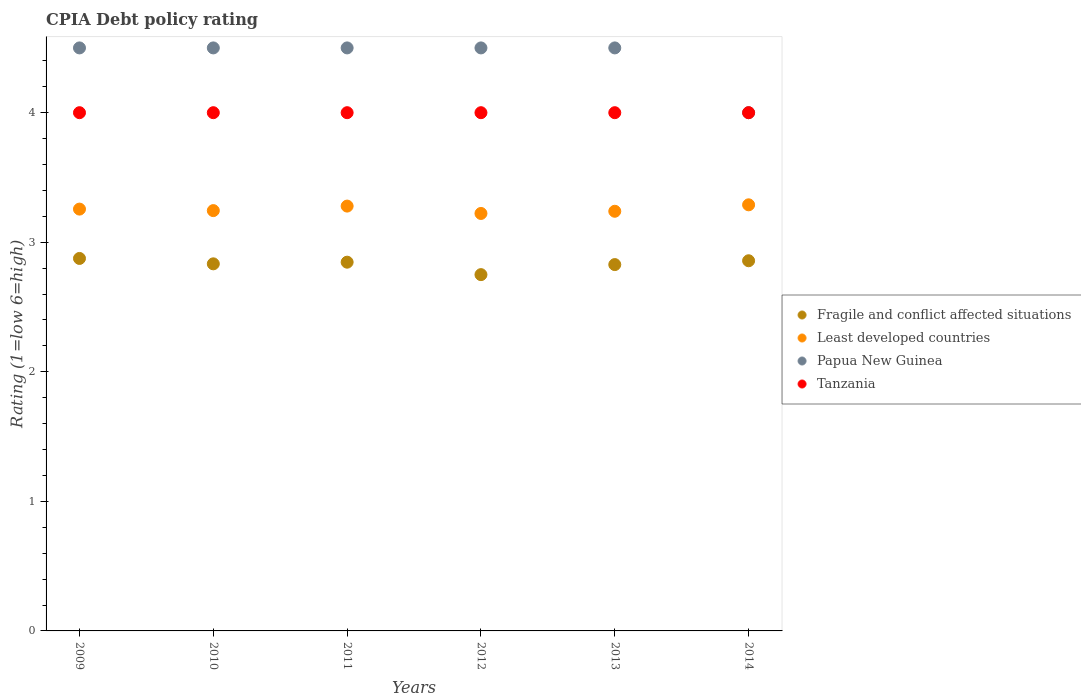How many different coloured dotlines are there?
Provide a succinct answer. 4. Is the number of dotlines equal to the number of legend labels?
Your answer should be very brief. Yes. What is the CPIA rating in Least developed countries in 2010?
Provide a succinct answer. 3.24. Across all years, what is the minimum CPIA rating in Papua New Guinea?
Provide a short and direct response. 4. What is the total CPIA rating in Fragile and conflict affected situations in the graph?
Your answer should be compact. 16.99. What is the difference between the CPIA rating in Least developed countries in 2009 and that in 2011?
Your response must be concise. -0.02. What is the difference between the CPIA rating in Least developed countries in 2010 and the CPIA rating in Fragile and conflict affected situations in 2012?
Ensure brevity in your answer.  0.49. What is the average CPIA rating in Fragile and conflict affected situations per year?
Offer a very short reply. 2.83. In the year 2009, what is the difference between the CPIA rating in Least developed countries and CPIA rating in Papua New Guinea?
Make the answer very short. -1.24. In how many years, is the CPIA rating in Tanzania greater than 4.2?
Make the answer very short. 0. What is the ratio of the CPIA rating in Least developed countries in 2011 to that in 2013?
Offer a terse response. 1.01. Is the difference between the CPIA rating in Least developed countries in 2009 and 2013 greater than the difference between the CPIA rating in Papua New Guinea in 2009 and 2013?
Ensure brevity in your answer.  Yes. What is the difference between the highest and the second highest CPIA rating in Papua New Guinea?
Give a very brief answer. 0. Is it the case that in every year, the sum of the CPIA rating in Tanzania and CPIA rating in Papua New Guinea  is greater than the CPIA rating in Least developed countries?
Your answer should be very brief. Yes. Does the CPIA rating in Fragile and conflict affected situations monotonically increase over the years?
Give a very brief answer. No. Is the CPIA rating in Tanzania strictly less than the CPIA rating in Fragile and conflict affected situations over the years?
Keep it short and to the point. No. How many dotlines are there?
Offer a terse response. 4. How many years are there in the graph?
Offer a very short reply. 6. What is the difference between two consecutive major ticks on the Y-axis?
Give a very brief answer. 1. Are the values on the major ticks of Y-axis written in scientific E-notation?
Your response must be concise. No. Does the graph contain any zero values?
Keep it short and to the point. No. How are the legend labels stacked?
Provide a succinct answer. Vertical. What is the title of the graph?
Provide a succinct answer. CPIA Debt policy rating. What is the label or title of the X-axis?
Provide a succinct answer. Years. What is the Rating (1=low 6=high) of Fragile and conflict affected situations in 2009?
Give a very brief answer. 2.88. What is the Rating (1=low 6=high) of Least developed countries in 2009?
Make the answer very short. 3.26. What is the Rating (1=low 6=high) of Fragile and conflict affected situations in 2010?
Keep it short and to the point. 2.83. What is the Rating (1=low 6=high) in Least developed countries in 2010?
Offer a terse response. 3.24. What is the Rating (1=low 6=high) in Tanzania in 2010?
Provide a succinct answer. 4. What is the Rating (1=low 6=high) in Fragile and conflict affected situations in 2011?
Give a very brief answer. 2.85. What is the Rating (1=low 6=high) of Least developed countries in 2011?
Your response must be concise. 3.28. What is the Rating (1=low 6=high) in Papua New Guinea in 2011?
Provide a short and direct response. 4.5. What is the Rating (1=low 6=high) in Fragile and conflict affected situations in 2012?
Keep it short and to the point. 2.75. What is the Rating (1=low 6=high) in Least developed countries in 2012?
Keep it short and to the point. 3.22. What is the Rating (1=low 6=high) in Papua New Guinea in 2012?
Your response must be concise. 4.5. What is the Rating (1=low 6=high) in Fragile and conflict affected situations in 2013?
Your answer should be compact. 2.83. What is the Rating (1=low 6=high) in Least developed countries in 2013?
Keep it short and to the point. 3.24. What is the Rating (1=low 6=high) in Tanzania in 2013?
Provide a short and direct response. 4. What is the Rating (1=low 6=high) of Fragile and conflict affected situations in 2014?
Give a very brief answer. 2.86. What is the Rating (1=low 6=high) in Least developed countries in 2014?
Ensure brevity in your answer.  3.29. What is the Rating (1=low 6=high) of Tanzania in 2014?
Ensure brevity in your answer.  4. Across all years, what is the maximum Rating (1=low 6=high) in Fragile and conflict affected situations?
Ensure brevity in your answer.  2.88. Across all years, what is the maximum Rating (1=low 6=high) of Least developed countries?
Offer a very short reply. 3.29. Across all years, what is the minimum Rating (1=low 6=high) of Fragile and conflict affected situations?
Provide a short and direct response. 2.75. Across all years, what is the minimum Rating (1=low 6=high) of Least developed countries?
Keep it short and to the point. 3.22. What is the total Rating (1=low 6=high) in Fragile and conflict affected situations in the graph?
Offer a terse response. 16.99. What is the total Rating (1=low 6=high) in Least developed countries in the graph?
Your answer should be compact. 19.53. What is the total Rating (1=low 6=high) in Tanzania in the graph?
Offer a very short reply. 24. What is the difference between the Rating (1=low 6=high) in Fragile and conflict affected situations in 2009 and that in 2010?
Keep it short and to the point. 0.04. What is the difference between the Rating (1=low 6=high) in Least developed countries in 2009 and that in 2010?
Offer a very short reply. 0.01. What is the difference between the Rating (1=low 6=high) in Tanzania in 2009 and that in 2010?
Your answer should be very brief. 0. What is the difference between the Rating (1=low 6=high) in Fragile and conflict affected situations in 2009 and that in 2011?
Your answer should be very brief. 0.03. What is the difference between the Rating (1=low 6=high) of Least developed countries in 2009 and that in 2011?
Keep it short and to the point. -0.02. What is the difference between the Rating (1=low 6=high) of Papua New Guinea in 2009 and that in 2011?
Keep it short and to the point. 0. What is the difference between the Rating (1=low 6=high) in Least developed countries in 2009 and that in 2012?
Provide a short and direct response. 0.03. What is the difference between the Rating (1=low 6=high) in Papua New Guinea in 2009 and that in 2012?
Ensure brevity in your answer.  0. What is the difference between the Rating (1=low 6=high) in Tanzania in 2009 and that in 2012?
Your answer should be compact. 0. What is the difference between the Rating (1=low 6=high) of Fragile and conflict affected situations in 2009 and that in 2013?
Ensure brevity in your answer.  0.05. What is the difference between the Rating (1=low 6=high) of Least developed countries in 2009 and that in 2013?
Make the answer very short. 0.02. What is the difference between the Rating (1=low 6=high) of Papua New Guinea in 2009 and that in 2013?
Offer a very short reply. 0. What is the difference between the Rating (1=low 6=high) in Tanzania in 2009 and that in 2013?
Provide a succinct answer. 0. What is the difference between the Rating (1=low 6=high) in Fragile and conflict affected situations in 2009 and that in 2014?
Provide a succinct answer. 0.02. What is the difference between the Rating (1=low 6=high) of Least developed countries in 2009 and that in 2014?
Make the answer very short. -0.03. What is the difference between the Rating (1=low 6=high) in Tanzania in 2009 and that in 2014?
Offer a terse response. 0. What is the difference between the Rating (1=low 6=high) in Fragile and conflict affected situations in 2010 and that in 2011?
Ensure brevity in your answer.  -0.01. What is the difference between the Rating (1=low 6=high) in Least developed countries in 2010 and that in 2011?
Offer a very short reply. -0.03. What is the difference between the Rating (1=low 6=high) in Fragile and conflict affected situations in 2010 and that in 2012?
Ensure brevity in your answer.  0.08. What is the difference between the Rating (1=low 6=high) in Least developed countries in 2010 and that in 2012?
Give a very brief answer. 0.02. What is the difference between the Rating (1=low 6=high) of Tanzania in 2010 and that in 2012?
Offer a very short reply. 0. What is the difference between the Rating (1=low 6=high) in Fragile and conflict affected situations in 2010 and that in 2013?
Your answer should be very brief. 0.01. What is the difference between the Rating (1=low 6=high) of Least developed countries in 2010 and that in 2013?
Your answer should be very brief. 0.01. What is the difference between the Rating (1=low 6=high) in Papua New Guinea in 2010 and that in 2013?
Keep it short and to the point. 0. What is the difference between the Rating (1=low 6=high) of Tanzania in 2010 and that in 2013?
Your answer should be very brief. 0. What is the difference between the Rating (1=low 6=high) of Fragile and conflict affected situations in 2010 and that in 2014?
Provide a succinct answer. -0.02. What is the difference between the Rating (1=low 6=high) of Least developed countries in 2010 and that in 2014?
Your answer should be very brief. -0.04. What is the difference between the Rating (1=low 6=high) of Papua New Guinea in 2010 and that in 2014?
Provide a short and direct response. 0.5. What is the difference between the Rating (1=low 6=high) of Fragile and conflict affected situations in 2011 and that in 2012?
Ensure brevity in your answer.  0.1. What is the difference between the Rating (1=low 6=high) in Least developed countries in 2011 and that in 2012?
Offer a terse response. 0.06. What is the difference between the Rating (1=low 6=high) of Fragile and conflict affected situations in 2011 and that in 2013?
Provide a succinct answer. 0.02. What is the difference between the Rating (1=low 6=high) in Least developed countries in 2011 and that in 2013?
Make the answer very short. 0.04. What is the difference between the Rating (1=low 6=high) in Papua New Guinea in 2011 and that in 2013?
Offer a terse response. 0. What is the difference between the Rating (1=low 6=high) of Fragile and conflict affected situations in 2011 and that in 2014?
Offer a terse response. -0.01. What is the difference between the Rating (1=low 6=high) of Least developed countries in 2011 and that in 2014?
Your answer should be compact. -0.01. What is the difference between the Rating (1=low 6=high) of Papua New Guinea in 2011 and that in 2014?
Your answer should be compact. 0.5. What is the difference between the Rating (1=low 6=high) of Fragile and conflict affected situations in 2012 and that in 2013?
Offer a very short reply. -0.08. What is the difference between the Rating (1=low 6=high) in Least developed countries in 2012 and that in 2013?
Make the answer very short. -0.02. What is the difference between the Rating (1=low 6=high) in Papua New Guinea in 2012 and that in 2013?
Give a very brief answer. 0. What is the difference between the Rating (1=low 6=high) of Fragile and conflict affected situations in 2012 and that in 2014?
Ensure brevity in your answer.  -0.11. What is the difference between the Rating (1=low 6=high) in Least developed countries in 2012 and that in 2014?
Offer a terse response. -0.07. What is the difference between the Rating (1=low 6=high) of Papua New Guinea in 2012 and that in 2014?
Your answer should be very brief. 0.5. What is the difference between the Rating (1=low 6=high) in Fragile and conflict affected situations in 2013 and that in 2014?
Provide a succinct answer. -0.03. What is the difference between the Rating (1=low 6=high) of Least developed countries in 2013 and that in 2014?
Your answer should be compact. -0.05. What is the difference between the Rating (1=low 6=high) in Papua New Guinea in 2013 and that in 2014?
Give a very brief answer. 0.5. What is the difference between the Rating (1=low 6=high) of Fragile and conflict affected situations in 2009 and the Rating (1=low 6=high) of Least developed countries in 2010?
Give a very brief answer. -0.37. What is the difference between the Rating (1=low 6=high) of Fragile and conflict affected situations in 2009 and the Rating (1=low 6=high) of Papua New Guinea in 2010?
Give a very brief answer. -1.62. What is the difference between the Rating (1=low 6=high) of Fragile and conflict affected situations in 2009 and the Rating (1=low 6=high) of Tanzania in 2010?
Offer a terse response. -1.12. What is the difference between the Rating (1=low 6=high) in Least developed countries in 2009 and the Rating (1=low 6=high) in Papua New Guinea in 2010?
Offer a terse response. -1.24. What is the difference between the Rating (1=low 6=high) of Least developed countries in 2009 and the Rating (1=low 6=high) of Tanzania in 2010?
Give a very brief answer. -0.74. What is the difference between the Rating (1=low 6=high) in Fragile and conflict affected situations in 2009 and the Rating (1=low 6=high) in Least developed countries in 2011?
Give a very brief answer. -0.4. What is the difference between the Rating (1=low 6=high) of Fragile and conflict affected situations in 2009 and the Rating (1=low 6=high) of Papua New Guinea in 2011?
Offer a very short reply. -1.62. What is the difference between the Rating (1=low 6=high) in Fragile and conflict affected situations in 2009 and the Rating (1=low 6=high) in Tanzania in 2011?
Your response must be concise. -1.12. What is the difference between the Rating (1=low 6=high) in Least developed countries in 2009 and the Rating (1=low 6=high) in Papua New Guinea in 2011?
Give a very brief answer. -1.24. What is the difference between the Rating (1=low 6=high) of Least developed countries in 2009 and the Rating (1=low 6=high) of Tanzania in 2011?
Make the answer very short. -0.74. What is the difference between the Rating (1=low 6=high) in Papua New Guinea in 2009 and the Rating (1=low 6=high) in Tanzania in 2011?
Make the answer very short. 0.5. What is the difference between the Rating (1=low 6=high) in Fragile and conflict affected situations in 2009 and the Rating (1=low 6=high) in Least developed countries in 2012?
Your response must be concise. -0.35. What is the difference between the Rating (1=low 6=high) in Fragile and conflict affected situations in 2009 and the Rating (1=low 6=high) in Papua New Guinea in 2012?
Your response must be concise. -1.62. What is the difference between the Rating (1=low 6=high) in Fragile and conflict affected situations in 2009 and the Rating (1=low 6=high) in Tanzania in 2012?
Provide a succinct answer. -1.12. What is the difference between the Rating (1=low 6=high) in Least developed countries in 2009 and the Rating (1=low 6=high) in Papua New Guinea in 2012?
Give a very brief answer. -1.24. What is the difference between the Rating (1=low 6=high) in Least developed countries in 2009 and the Rating (1=low 6=high) in Tanzania in 2012?
Keep it short and to the point. -0.74. What is the difference between the Rating (1=low 6=high) of Papua New Guinea in 2009 and the Rating (1=low 6=high) of Tanzania in 2012?
Your answer should be compact. 0.5. What is the difference between the Rating (1=low 6=high) of Fragile and conflict affected situations in 2009 and the Rating (1=low 6=high) of Least developed countries in 2013?
Give a very brief answer. -0.36. What is the difference between the Rating (1=low 6=high) of Fragile and conflict affected situations in 2009 and the Rating (1=low 6=high) of Papua New Guinea in 2013?
Give a very brief answer. -1.62. What is the difference between the Rating (1=low 6=high) in Fragile and conflict affected situations in 2009 and the Rating (1=low 6=high) in Tanzania in 2013?
Make the answer very short. -1.12. What is the difference between the Rating (1=low 6=high) in Least developed countries in 2009 and the Rating (1=low 6=high) in Papua New Guinea in 2013?
Make the answer very short. -1.24. What is the difference between the Rating (1=low 6=high) of Least developed countries in 2009 and the Rating (1=low 6=high) of Tanzania in 2013?
Keep it short and to the point. -0.74. What is the difference between the Rating (1=low 6=high) in Papua New Guinea in 2009 and the Rating (1=low 6=high) in Tanzania in 2013?
Give a very brief answer. 0.5. What is the difference between the Rating (1=low 6=high) in Fragile and conflict affected situations in 2009 and the Rating (1=low 6=high) in Least developed countries in 2014?
Offer a terse response. -0.41. What is the difference between the Rating (1=low 6=high) in Fragile and conflict affected situations in 2009 and the Rating (1=low 6=high) in Papua New Guinea in 2014?
Your answer should be very brief. -1.12. What is the difference between the Rating (1=low 6=high) in Fragile and conflict affected situations in 2009 and the Rating (1=low 6=high) in Tanzania in 2014?
Your answer should be very brief. -1.12. What is the difference between the Rating (1=low 6=high) in Least developed countries in 2009 and the Rating (1=low 6=high) in Papua New Guinea in 2014?
Your answer should be compact. -0.74. What is the difference between the Rating (1=low 6=high) of Least developed countries in 2009 and the Rating (1=low 6=high) of Tanzania in 2014?
Your response must be concise. -0.74. What is the difference between the Rating (1=low 6=high) in Fragile and conflict affected situations in 2010 and the Rating (1=low 6=high) in Least developed countries in 2011?
Provide a short and direct response. -0.45. What is the difference between the Rating (1=low 6=high) of Fragile and conflict affected situations in 2010 and the Rating (1=low 6=high) of Papua New Guinea in 2011?
Give a very brief answer. -1.67. What is the difference between the Rating (1=low 6=high) in Fragile and conflict affected situations in 2010 and the Rating (1=low 6=high) in Tanzania in 2011?
Give a very brief answer. -1.17. What is the difference between the Rating (1=low 6=high) in Least developed countries in 2010 and the Rating (1=low 6=high) in Papua New Guinea in 2011?
Keep it short and to the point. -1.26. What is the difference between the Rating (1=low 6=high) of Least developed countries in 2010 and the Rating (1=low 6=high) of Tanzania in 2011?
Make the answer very short. -0.76. What is the difference between the Rating (1=low 6=high) of Papua New Guinea in 2010 and the Rating (1=low 6=high) of Tanzania in 2011?
Your answer should be very brief. 0.5. What is the difference between the Rating (1=low 6=high) of Fragile and conflict affected situations in 2010 and the Rating (1=low 6=high) of Least developed countries in 2012?
Give a very brief answer. -0.39. What is the difference between the Rating (1=low 6=high) of Fragile and conflict affected situations in 2010 and the Rating (1=low 6=high) of Papua New Guinea in 2012?
Provide a succinct answer. -1.67. What is the difference between the Rating (1=low 6=high) of Fragile and conflict affected situations in 2010 and the Rating (1=low 6=high) of Tanzania in 2012?
Keep it short and to the point. -1.17. What is the difference between the Rating (1=low 6=high) of Least developed countries in 2010 and the Rating (1=low 6=high) of Papua New Guinea in 2012?
Offer a very short reply. -1.26. What is the difference between the Rating (1=low 6=high) in Least developed countries in 2010 and the Rating (1=low 6=high) in Tanzania in 2012?
Offer a terse response. -0.76. What is the difference between the Rating (1=low 6=high) of Fragile and conflict affected situations in 2010 and the Rating (1=low 6=high) of Least developed countries in 2013?
Your answer should be compact. -0.41. What is the difference between the Rating (1=low 6=high) of Fragile and conflict affected situations in 2010 and the Rating (1=low 6=high) of Papua New Guinea in 2013?
Offer a very short reply. -1.67. What is the difference between the Rating (1=low 6=high) in Fragile and conflict affected situations in 2010 and the Rating (1=low 6=high) in Tanzania in 2013?
Provide a succinct answer. -1.17. What is the difference between the Rating (1=low 6=high) in Least developed countries in 2010 and the Rating (1=low 6=high) in Papua New Guinea in 2013?
Your answer should be compact. -1.26. What is the difference between the Rating (1=low 6=high) in Least developed countries in 2010 and the Rating (1=low 6=high) in Tanzania in 2013?
Ensure brevity in your answer.  -0.76. What is the difference between the Rating (1=low 6=high) of Papua New Guinea in 2010 and the Rating (1=low 6=high) of Tanzania in 2013?
Provide a succinct answer. 0.5. What is the difference between the Rating (1=low 6=high) in Fragile and conflict affected situations in 2010 and the Rating (1=low 6=high) in Least developed countries in 2014?
Provide a succinct answer. -0.46. What is the difference between the Rating (1=low 6=high) of Fragile and conflict affected situations in 2010 and the Rating (1=low 6=high) of Papua New Guinea in 2014?
Provide a short and direct response. -1.17. What is the difference between the Rating (1=low 6=high) of Fragile and conflict affected situations in 2010 and the Rating (1=low 6=high) of Tanzania in 2014?
Keep it short and to the point. -1.17. What is the difference between the Rating (1=low 6=high) of Least developed countries in 2010 and the Rating (1=low 6=high) of Papua New Guinea in 2014?
Make the answer very short. -0.76. What is the difference between the Rating (1=low 6=high) of Least developed countries in 2010 and the Rating (1=low 6=high) of Tanzania in 2014?
Your answer should be very brief. -0.76. What is the difference between the Rating (1=low 6=high) of Fragile and conflict affected situations in 2011 and the Rating (1=low 6=high) of Least developed countries in 2012?
Your answer should be very brief. -0.38. What is the difference between the Rating (1=low 6=high) in Fragile and conflict affected situations in 2011 and the Rating (1=low 6=high) in Papua New Guinea in 2012?
Provide a succinct answer. -1.65. What is the difference between the Rating (1=low 6=high) of Fragile and conflict affected situations in 2011 and the Rating (1=low 6=high) of Tanzania in 2012?
Give a very brief answer. -1.15. What is the difference between the Rating (1=low 6=high) of Least developed countries in 2011 and the Rating (1=low 6=high) of Papua New Guinea in 2012?
Offer a very short reply. -1.22. What is the difference between the Rating (1=low 6=high) of Least developed countries in 2011 and the Rating (1=low 6=high) of Tanzania in 2012?
Your response must be concise. -0.72. What is the difference between the Rating (1=low 6=high) of Fragile and conflict affected situations in 2011 and the Rating (1=low 6=high) of Least developed countries in 2013?
Offer a very short reply. -0.39. What is the difference between the Rating (1=low 6=high) of Fragile and conflict affected situations in 2011 and the Rating (1=low 6=high) of Papua New Guinea in 2013?
Provide a short and direct response. -1.65. What is the difference between the Rating (1=low 6=high) in Fragile and conflict affected situations in 2011 and the Rating (1=low 6=high) in Tanzania in 2013?
Ensure brevity in your answer.  -1.15. What is the difference between the Rating (1=low 6=high) of Least developed countries in 2011 and the Rating (1=low 6=high) of Papua New Guinea in 2013?
Provide a succinct answer. -1.22. What is the difference between the Rating (1=low 6=high) of Least developed countries in 2011 and the Rating (1=low 6=high) of Tanzania in 2013?
Offer a very short reply. -0.72. What is the difference between the Rating (1=low 6=high) in Fragile and conflict affected situations in 2011 and the Rating (1=low 6=high) in Least developed countries in 2014?
Provide a short and direct response. -0.44. What is the difference between the Rating (1=low 6=high) in Fragile and conflict affected situations in 2011 and the Rating (1=low 6=high) in Papua New Guinea in 2014?
Keep it short and to the point. -1.15. What is the difference between the Rating (1=low 6=high) of Fragile and conflict affected situations in 2011 and the Rating (1=low 6=high) of Tanzania in 2014?
Make the answer very short. -1.15. What is the difference between the Rating (1=low 6=high) in Least developed countries in 2011 and the Rating (1=low 6=high) in Papua New Guinea in 2014?
Give a very brief answer. -0.72. What is the difference between the Rating (1=low 6=high) of Least developed countries in 2011 and the Rating (1=low 6=high) of Tanzania in 2014?
Your answer should be compact. -0.72. What is the difference between the Rating (1=low 6=high) of Papua New Guinea in 2011 and the Rating (1=low 6=high) of Tanzania in 2014?
Provide a succinct answer. 0.5. What is the difference between the Rating (1=low 6=high) in Fragile and conflict affected situations in 2012 and the Rating (1=low 6=high) in Least developed countries in 2013?
Provide a short and direct response. -0.49. What is the difference between the Rating (1=low 6=high) in Fragile and conflict affected situations in 2012 and the Rating (1=low 6=high) in Papua New Guinea in 2013?
Ensure brevity in your answer.  -1.75. What is the difference between the Rating (1=low 6=high) in Fragile and conflict affected situations in 2012 and the Rating (1=low 6=high) in Tanzania in 2013?
Your answer should be compact. -1.25. What is the difference between the Rating (1=low 6=high) of Least developed countries in 2012 and the Rating (1=low 6=high) of Papua New Guinea in 2013?
Provide a short and direct response. -1.28. What is the difference between the Rating (1=low 6=high) in Least developed countries in 2012 and the Rating (1=low 6=high) in Tanzania in 2013?
Provide a short and direct response. -0.78. What is the difference between the Rating (1=low 6=high) in Fragile and conflict affected situations in 2012 and the Rating (1=low 6=high) in Least developed countries in 2014?
Give a very brief answer. -0.54. What is the difference between the Rating (1=low 6=high) of Fragile and conflict affected situations in 2012 and the Rating (1=low 6=high) of Papua New Guinea in 2014?
Provide a succinct answer. -1.25. What is the difference between the Rating (1=low 6=high) in Fragile and conflict affected situations in 2012 and the Rating (1=low 6=high) in Tanzania in 2014?
Your answer should be compact. -1.25. What is the difference between the Rating (1=low 6=high) of Least developed countries in 2012 and the Rating (1=low 6=high) of Papua New Guinea in 2014?
Your response must be concise. -0.78. What is the difference between the Rating (1=low 6=high) of Least developed countries in 2012 and the Rating (1=low 6=high) of Tanzania in 2014?
Your answer should be compact. -0.78. What is the difference between the Rating (1=low 6=high) of Fragile and conflict affected situations in 2013 and the Rating (1=low 6=high) of Least developed countries in 2014?
Keep it short and to the point. -0.46. What is the difference between the Rating (1=low 6=high) of Fragile and conflict affected situations in 2013 and the Rating (1=low 6=high) of Papua New Guinea in 2014?
Ensure brevity in your answer.  -1.17. What is the difference between the Rating (1=low 6=high) of Fragile and conflict affected situations in 2013 and the Rating (1=low 6=high) of Tanzania in 2014?
Keep it short and to the point. -1.17. What is the difference between the Rating (1=low 6=high) in Least developed countries in 2013 and the Rating (1=low 6=high) in Papua New Guinea in 2014?
Ensure brevity in your answer.  -0.76. What is the difference between the Rating (1=low 6=high) in Least developed countries in 2013 and the Rating (1=low 6=high) in Tanzania in 2014?
Make the answer very short. -0.76. What is the difference between the Rating (1=low 6=high) of Papua New Guinea in 2013 and the Rating (1=low 6=high) of Tanzania in 2014?
Your answer should be compact. 0.5. What is the average Rating (1=low 6=high) in Fragile and conflict affected situations per year?
Ensure brevity in your answer.  2.83. What is the average Rating (1=low 6=high) of Least developed countries per year?
Your answer should be very brief. 3.25. What is the average Rating (1=low 6=high) in Papua New Guinea per year?
Your answer should be very brief. 4.42. What is the average Rating (1=low 6=high) in Tanzania per year?
Keep it short and to the point. 4. In the year 2009, what is the difference between the Rating (1=low 6=high) of Fragile and conflict affected situations and Rating (1=low 6=high) of Least developed countries?
Your response must be concise. -0.38. In the year 2009, what is the difference between the Rating (1=low 6=high) of Fragile and conflict affected situations and Rating (1=low 6=high) of Papua New Guinea?
Make the answer very short. -1.62. In the year 2009, what is the difference between the Rating (1=low 6=high) of Fragile and conflict affected situations and Rating (1=low 6=high) of Tanzania?
Provide a succinct answer. -1.12. In the year 2009, what is the difference between the Rating (1=low 6=high) of Least developed countries and Rating (1=low 6=high) of Papua New Guinea?
Your answer should be very brief. -1.24. In the year 2009, what is the difference between the Rating (1=low 6=high) in Least developed countries and Rating (1=low 6=high) in Tanzania?
Provide a short and direct response. -0.74. In the year 2010, what is the difference between the Rating (1=low 6=high) in Fragile and conflict affected situations and Rating (1=low 6=high) in Least developed countries?
Give a very brief answer. -0.41. In the year 2010, what is the difference between the Rating (1=low 6=high) of Fragile and conflict affected situations and Rating (1=low 6=high) of Papua New Guinea?
Your answer should be very brief. -1.67. In the year 2010, what is the difference between the Rating (1=low 6=high) of Fragile and conflict affected situations and Rating (1=low 6=high) of Tanzania?
Offer a very short reply. -1.17. In the year 2010, what is the difference between the Rating (1=low 6=high) in Least developed countries and Rating (1=low 6=high) in Papua New Guinea?
Your answer should be very brief. -1.26. In the year 2010, what is the difference between the Rating (1=low 6=high) of Least developed countries and Rating (1=low 6=high) of Tanzania?
Your answer should be very brief. -0.76. In the year 2011, what is the difference between the Rating (1=low 6=high) in Fragile and conflict affected situations and Rating (1=low 6=high) in Least developed countries?
Make the answer very short. -0.43. In the year 2011, what is the difference between the Rating (1=low 6=high) in Fragile and conflict affected situations and Rating (1=low 6=high) in Papua New Guinea?
Give a very brief answer. -1.65. In the year 2011, what is the difference between the Rating (1=low 6=high) of Fragile and conflict affected situations and Rating (1=low 6=high) of Tanzania?
Provide a short and direct response. -1.15. In the year 2011, what is the difference between the Rating (1=low 6=high) in Least developed countries and Rating (1=low 6=high) in Papua New Guinea?
Your answer should be compact. -1.22. In the year 2011, what is the difference between the Rating (1=low 6=high) of Least developed countries and Rating (1=low 6=high) of Tanzania?
Offer a terse response. -0.72. In the year 2011, what is the difference between the Rating (1=low 6=high) in Papua New Guinea and Rating (1=low 6=high) in Tanzania?
Your answer should be compact. 0.5. In the year 2012, what is the difference between the Rating (1=low 6=high) of Fragile and conflict affected situations and Rating (1=low 6=high) of Least developed countries?
Make the answer very short. -0.47. In the year 2012, what is the difference between the Rating (1=low 6=high) of Fragile and conflict affected situations and Rating (1=low 6=high) of Papua New Guinea?
Your response must be concise. -1.75. In the year 2012, what is the difference between the Rating (1=low 6=high) of Fragile and conflict affected situations and Rating (1=low 6=high) of Tanzania?
Give a very brief answer. -1.25. In the year 2012, what is the difference between the Rating (1=low 6=high) of Least developed countries and Rating (1=low 6=high) of Papua New Guinea?
Your answer should be very brief. -1.28. In the year 2012, what is the difference between the Rating (1=low 6=high) in Least developed countries and Rating (1=low 6=high) in Tanzania?
Offer a very short reply. -0.78. In the year 2013, what is the difference between the Rating (1=low 6=high) in Fragile and conflict affected situations and Rating (1=low 6=high) in Least developed countries?
Keep it short and to the point. -0.41. In the year 2013, what is the difference between the Rating (1=low 6=high) in Fragile and conflict affected situations and Rating (1=low 6=high) in Papua New Guinea?
Make the answer very short. -1.67. In the year 2013, what is the difference between the Rating (1=low 6=high) in Fragile and conflict affected situations and Rating (1=low 6=high) in Tanzania?
Provide a short and direct response. -1.17. In the year 2013, what is the difference between the Rating (1=low 6=high) in Least developed countries and Rating (1=low 6=high) in Papua New Guinea?
Give a very brief answer. -1.26. In the year 2013, what is the difference between the Rating (1=low 6=high) of Least developed countries and Rating (1=low 6=high) of Tanzania?
Make the answer very short. -0.76. In the year 2013, what is the difference between the Rating (1=low 6=high) in Papua New Guinea and Rating (1=low 6=high) in Tanzania?
Provide a succinct answer. 0.5. In the year 2014, what is the difference between the Rating (1=low 6=high) in Fragile and conflict affected situations and Rating (1=low 6=high) in Least developed countries?
Keep it short and to the point. -0.43. In the year 2014, what is the difference between the Rating (1=low 6=high) of Fragile and conflict affected situations and Rating (1=low 6=high) of Papua New Guinea?
Keep it short and to the point. -1.14. In the year 2014, what is the difference between the Rating (1=low 6=high) in Fragile and conflict affected situations and Rating (1=low 6=high) in Tanzania?
Give a very brief answer. -1.14. In the year 2014, what is the difference between the Rating (1=low 6=high) of Least developed countries and Rating (1=low 6=high) of Papua New Guinea?
Make the answer very short. -0.71. In the year 2014, what is the difference between the Rating (1=low 6=high) in Least developed countries and Rating (1=low 6=high) in Tanzania?
Keep it short and to the point. -0.71. In the year 2014, what is the difference between the Rating (1=low 6=high) of Papua New Guinea and Rating (1=low 6=high) of Tanzania?
Ensure brevity in your answer.  0. What is the ratio of the Rating (1=low 6=high) of Fragile and conflict affected situations in 2009 to that in 2010?
Your answer should be very brief. 1.01. What is the ratio of the Rating (1=low 6=high) of Papua New Guinea in 2009 to that in 2010?
Offer a terse response. 1. What is the ratio of the Rating (1=low 6=high) of Least developed countries in 2009 to that in 2011?
Keep it short and to the point. 0.99. What is the ratio of the Rating (1=low 6=high) in Tanzania in 2009 to that in 2011?
Offer a very short reply. 1. What is the ratio of the Rating (1=low 6=high) in Fragile and conflict affected situations in 2009 to that in 2012?
Offer a very short reply. 1.05. What is the ratio of the Rating (1=low 6=high) in Least developed countries in 2009 to that in 2012?
Provide a succinct answer. 1.01. What is the ratio of the Rating (1=low 6=high) of Tanzania in 2009 to that in 2012?
Offer a very short reply. 1. What is the ratio of the Rating (1=low 6=high) in Fragile and conflict affected situations in 2009 to that in 2013?
Provide a short and direct response. 1.02. What is the ratio of the Rating (1=low 6=high) of Least developed countries in 2009 to that in 2013?
Your response must be concise. 1.01. What is the ratio of the Rating (1=low 6=high) of Papua New Guinea in 2009 to that in 2013?
Ensure brevity in your answer.  1. What is the ratio of the Rating (1=low 6=high) of Fragile and conflict affected situations in 2009 to that in 2014?
Make the answer very short. 1.01. What is the ratio of the Rating (1=low 6=high) in Papua New Guinea in 2009 to that in 2014?
Make the answer very short. 1.12. What is the ratio of the Rating (1=low 6=high) in Fragile and conflict affected situations in 2010 to that in 2011?
Your answer should be very brief. 1. What is the ratio of the Rating (1=low 6=high) in Least developed countries in 2010 to that in 2011?
Your answer should be compact. 0.99. What is the ratio of the Rating (1=low 6=high) in Tanzania in 2010 to that in 2011?
Make the answer very short. 1. What is the ratio of the Rating (1=low 6=high) of Fragile and conflict affected situations in 2010 to that in 2012?
Provide a short and direct response. 1.03. What is the ratio of the Rating (1=low 6=high) in Least developed countries in 2010 to that in 2012?
Ensure brevity in your answer.  1.01. What is the ratio of the Rating (1=low 6=high) of Papua New Guinea in 2010 to that in 2012?
Make the answer very short. 1. What is the ratio of the Rating (1=low 6=high) of Tanzania in 2010 to that in 2012?
Make the answer very short. 1. What is the ratio of the Rating (1=low 6=high) in Fragile and conflict affected situations in 2010 to that in 2014?
Provide a short and direct response. 0.99. What is the ratio of the Rating (1=low 6=high) of Least developed countries in 2010 to that in 2014?
Ensure brevity in your answer.  0.99. What is the ratio of the Rating (1=low 6=high) of Fragile and conflict affected situations in 2011 to that in 2012?
Make the answer very short. 1.03. What is the ratio of the Rating (1=low 6=high) in Least developed countries in 2011 to that in 2012?
Make the answer very short. 1.02. What is the ratio of the Rating (1=low 6=high) of Tanzania in 2011 to that in 2012?
Your answer should be compact. 1. What is the ratio of the Rating (1=low 6=high) of Fragile and conflict affected situations in 2011 to that in 2013?
Keep it short and to the point. 1.01. What is the ratio of the Rating (1=low 6=high) in Least developed countries in 2011 to that in 2013?
Provide a succinct answer. 1.01. What is the ratio of the Rating (1=low 6=high) in Papua New Guinea in 2011 to that in 2013?
Your response must be concise. 1. What is the ratio of the Rating (1=low 6=high) in Tanzania in 2011 to that in 2014?
Make the answer very short. 1. What is the ratio of the Rating (1=low 6=high) of Fragile and conflict affected situations in 2012 to that in 2013?
Provide a succinct answer. 0.97. What is the ratio of the Rating (1=low 6=high) in Least developed countries in 2012 to that in 2013?
Offer a very short reply. 0.99. What is the ratio of the Rating (1=low 6=high) of Fragile and conflict affected situations in 2012 to that in 2014?
Provide a succinct answer. 0.96. What is the ratio of the Rating (1=low 6=high) of Least developed countries in 2012 to that in 2014?
Provide a succinct answer. 0.98. What is the ratio of the Rating (1=low 6=high) of Fragile and conflict affected situations in 2013 to that in 2014?
Your answer should be compact. 0.99. What is the ratio of the Rating (1=low 6=high) of Least developed countries in 2013 to that in 2014?
Offer a terse response. 0.98. What is the difference between the highest and the second highest Rating (1=low 6=high) of Fragile and conflict affected situations?
Provide a succinct answer. 0.02. What is the difference between the highest and the second highest Rating (1=low 6=high) of Least developed countries?
Your response must be concise. 0.01. What is the difference between the highest and the second highest Rating (1=low 6=high) in Papua New Guinea?
Keep it short and to the point. 0. What is the difference between the highest and the second highest Rating (1=low 6=high) in Tanzania?
Make the answer very short. 0. What is the difference between the highest and the lowest Rating (1=low 6=high) of Fragile and conflict affected situations?
Offer a very short reply. 0.12. What is the difference between the highest and the lowest Rating (1=low 6=high) of Least developed countries?
Ensure brevity in your answer.  0.07. What is the difference between the highest and the lowest Rating (1=low 6=high) in Tanzania?
Offer a very short reply. 0. 